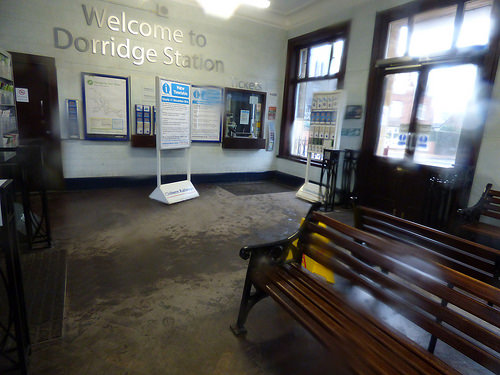<image>
Is there a bench next to the stand? No. The bench is not positioned next to the stand. They are located in different areas of the scene. 